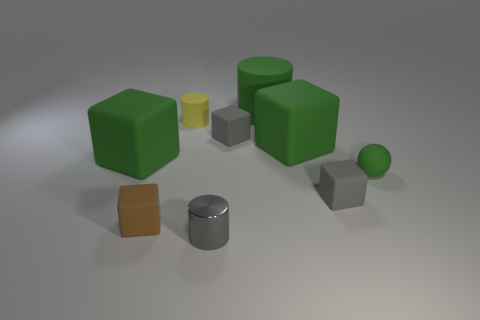Is the number of small cylinders less than the number of tiny yellow matte things?
Provide a succinct answer. No. There is a tiny gray matte thing behind the small gray rubber block that is in front of the small matte sphere; what shape is it?
Keep it short and to the point. Cube. Are there any gray cubes on the right side of the green rubber cylinder?
Your response must be concise. Yes. The other cylinder that is the same size as the yellow cylinder is what color?
Give a very brief answer. Gray. How many gray objects have the same material as the large green cylinder?
Ensure brevity in your answer.  2. How many other objects are the same size as the yellow matte cylinder?
Your answer should be compact. 5. Is there another yellow shiny object of the same size as the metal object?
Offer a very short reply. No. Do the big matte cube on the right side of the green cylinder and the small ball have the same color?
Provide a short and direct response. Yes. What number of objects are big gray matte cylinders or gray cylinders?
Ensure brevity in your answer.  1. There is a gray object behind the matte ball; is it the same size as the tiny brown matte object?
Give a very brief answer. Yes. 